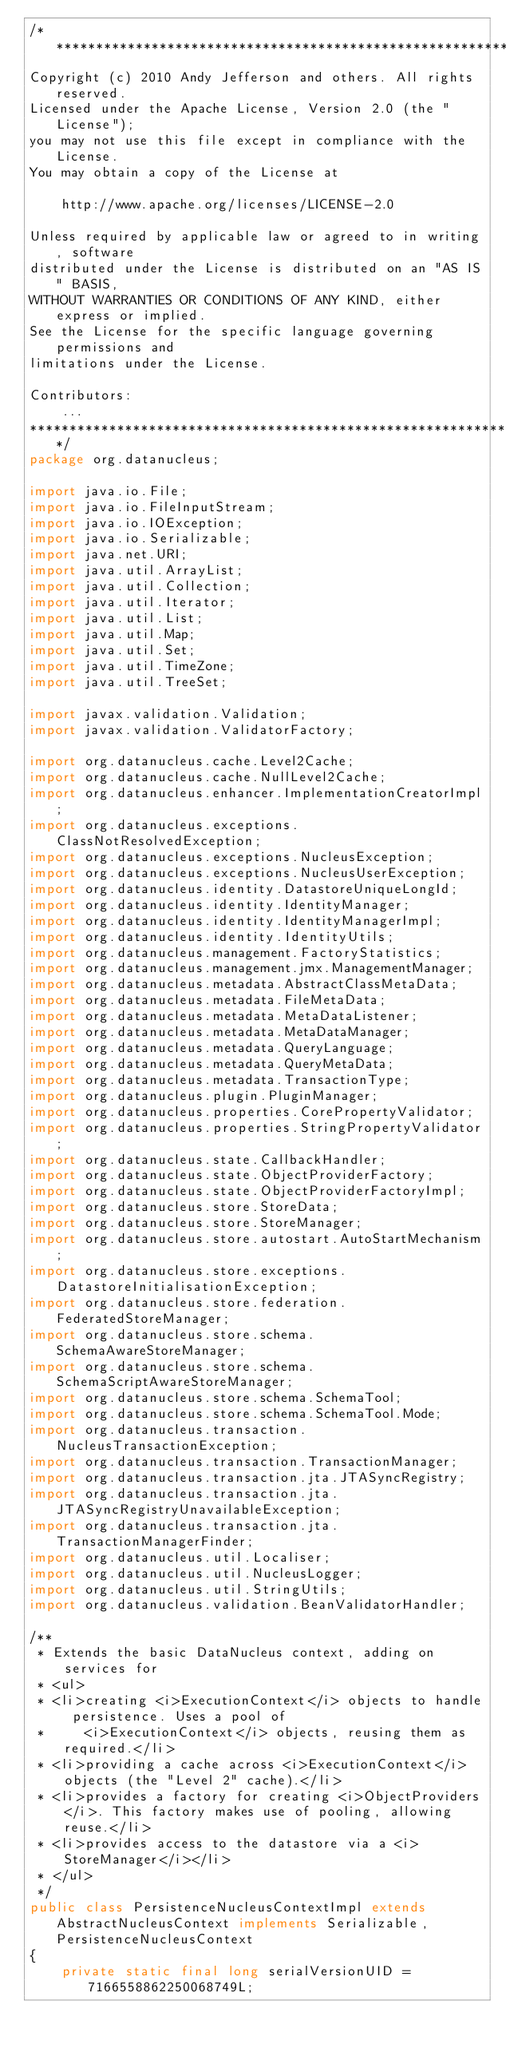<code> <loc_0><loc_0><loc_500><loc_500><_Java_>/**********************************************************************
Copyright (c) 2010 Andy Jefferson and others. All rights reserved.
Licensed under the Apache License, Version 2.0 (the "License");
you may not use this file except in compliance with the License.
You may obtain a copy of the License at

    http://www.apache.org/licenses/LICENSE-2.0

Unless required by applicable law or agreed to in writing, software
distributed under the License is distributed on an "AS IS" BASIS,
WITHOUT WARRANTIES OR CONDITIONS OF ANY KIND, either express or implied.
See the License for the specific language governing permissions and
limitations under the License. 

Contributors:
    ...
**********************************************************************/
package org.datanucleus;

import java.io.File;
import java.io.FileInputStream;
import java.io.IOException;
import java.io.Serializable;
import java.net.URI;
import java.util.ArrayList;
import java.util.Collection;
import java.util.Iterator;
import java.util.List;
import java.util.Map;
import java.util.Set;
import java.util.TimeZone;
import java.util.TreeSet;

import javax.validation.Validation;
import javax.validation.ValidatorFactory;

import org.datanucleus.cache.Level2Cache;
import org.datanucleus.cache.NullLevel2Cache;
import org.datanucleus.enhancer.ImplementationCreatorImpl;
import org.datanucleus.exceptions.ClassNotResolvedException;
import org.datanucleus.exceptions.NucleusException;
import org.datanucleus.exceptions.NucleusUserException;
import org.datanucleus.identity.DatastoreUniqueLongId;
import org.datanucleus.identity.IdentityManager;
import org.datanucleus.identity.IdentityManagerImpl;
import org.datanucleus.identity.IdentityUtils;
import org.datanucleus.management.FactoryStatistics;
import org.datanucleus.management.jmx.ManagementManager;
import org.datanucleus.metadata.AbstractClassMetaData;
import org.datanucleus.metadata.FileMetaData;
import org.datanucleus.metadata.MetaDataListener;
import org.datanucleus.metadata.MetaDataManager;
import org.datanucleus.metadata.QueryLanguage;
import org.datanucleus.metadata.QueryMetaData;
import org.datanucleus.metadata.TransactionType;
import org.datanucleus.plugin.PluginManager;
import org.datanucleus.properties.CorePropertyValidator;
import org.datanucleus.properties.StringPropertyValidator;
import org.datanucleus.state.CallbackHandler;
import org.datanucleus.state.ObjectProviderFactory;
import org.datanucleus.state.ObjectProviderFactoryImpl;
import org.datanucleus.store.StoreData;
import org.datanucleus.store.StoreManager;
import org.datanucleus.store.autostart.AutoStartMechanism;
import org.datanucleus.store.exceptions.DatastoreInitialisationException;
import org.datanucleus.store.federation.FederatedStoreManager;
import org.datanucleus.store.schema.SchemaAwareStoreManager;
import org.datanucleus.store.schema.SchemaScriptAwareStoreManager;
import org.datanucleus.store.schema.SchemaTool;
import org.datanucleus.store.schema.SchemaTool.Mode;
import org.datanucleus.transaction.NucleusTransactionException;
import org.datanucleus.transaction.TransactionManager;
import org.datanucleus.transaction.jta.JTASyncRegistry;
import org.datanucleus.transaction.jta.JTASyncRegistryUnavailableException;
import org.datanucleus.transaction.jta.TransactionManagerFinder;
import org.datanucleus.util.Localiser;
import org.datanucleus.util.NucleusLogger;
import org.datanucleus.util.StringUtils;
import org.datanucleus.validation.BeanValidatorHandler;

/**
 * Extends the basic DataNucleus context, adding on services for
 * <ul>
 * <li>creating <i>ExecutionContext</i> objects to handle persistence. Uses a pool of
 *     <i>ExecutionContext</i> objects, reusing them as required.</li>
 * <li>providing a cache across <i>ExecutionContext</i> objects (the "Level 2" cache).</li>
 * <li>provides a factory for creating <i>ObjectProviders</i>. This factory makes use of pooling, allowing reuse.</li>
 * <li>provides access to the datastore via a <i>StoreManager</i></li>
 * </ul>
 */
public class PersistenceNucleusContextImpl extends AbstractNucleusContext implements Serializable, PersistenceNucleusContext
{
    private static final long serialVersionUID = 7166558862250068749L;
</code> 